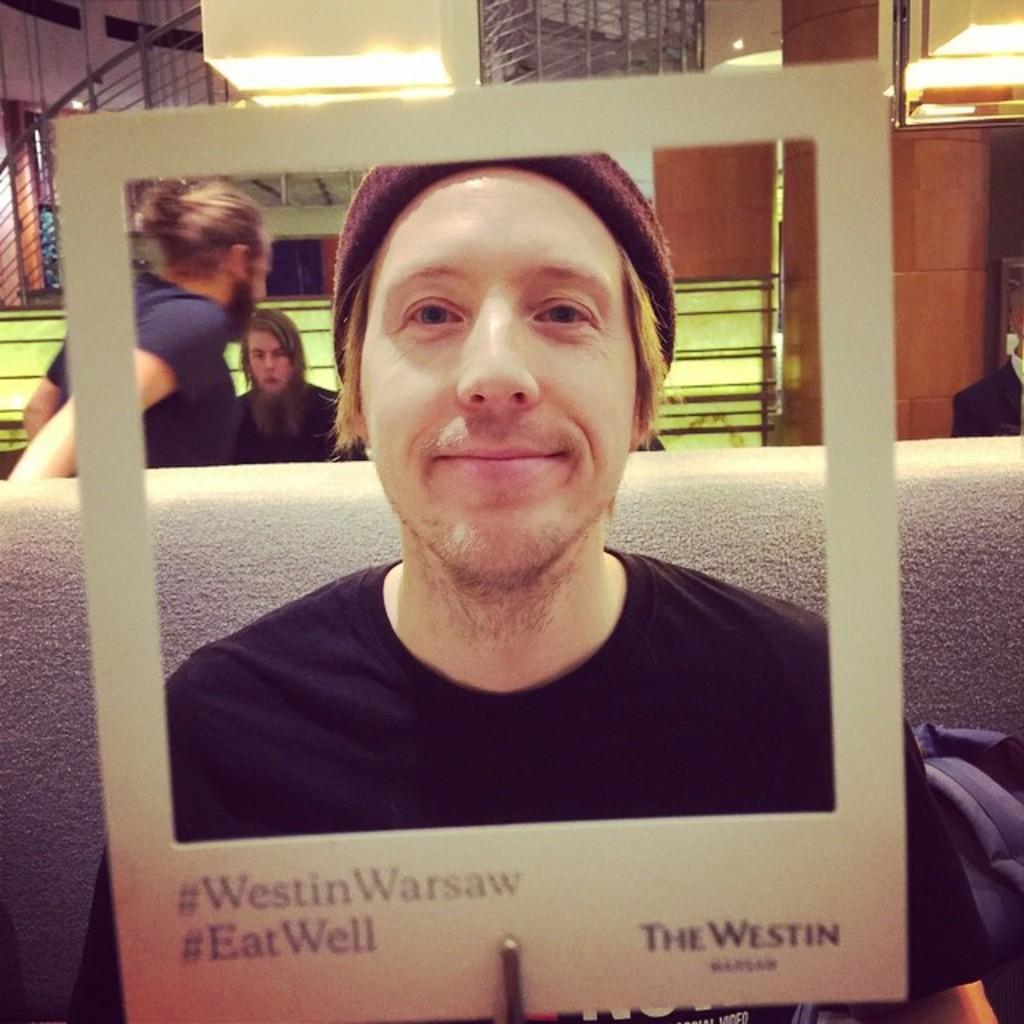Please provide a concise description of this image. In the center of the image there is a person sitting on the sofa. In the foreground there is a frame. In the background we can see persons, stairs, light and wall. 